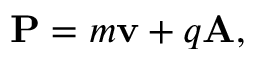<formula> <loc_0><loc_0><loc_500><loc_500>P = m \mathbf { v } + q A ,</formula> 